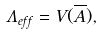<formula> <loc_0><loc_0><loc_500><loc_500>\Lambda _ { e f f } = V ( \overline { A } ) ,</formula> 